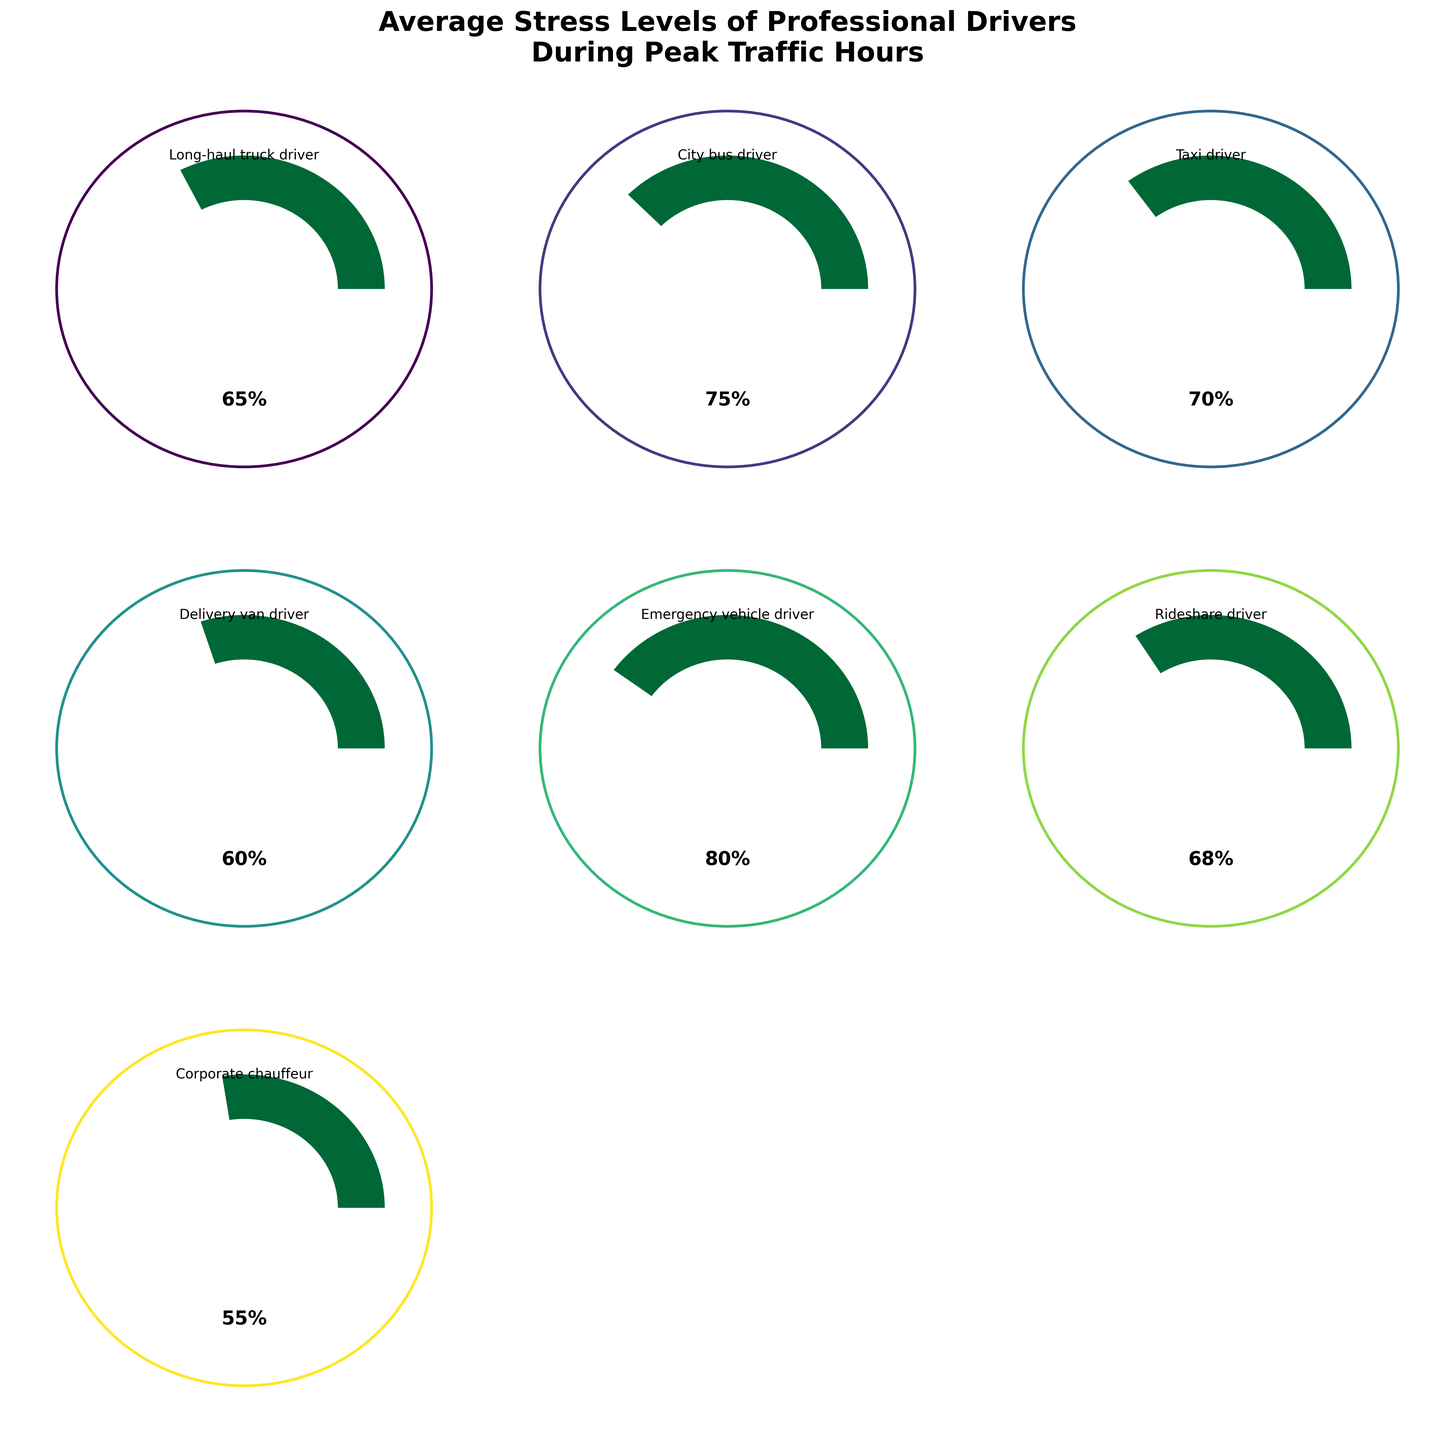What is the title of the figure? The title of the figure is usually the text displayed at the top of the chart. In this case, the title reads "Average Stress Levels of Professional Drivers\nDuring Peak Traffic Hours"
Answer: Average Stress Levels of Professional Drivers\nDuring Peak Traffic Hours How many driver types are displayed in the figure? The data provided lists seven types of professional drivers. The figure should display one gauge for each type of driver. Counting these will confirm the answer.
Answer: Seven Which driver type has the highest stress level? To determine the driver type with the highest stress level, locate the gauge showing the highest value of stress level. The stress level values are prominently displayed inside each gauge.
Answer: Emergency vehicle driver What is the average stress level of all professional drivers combined? Calculate the mean of all listed stress levels: (65 + 75 + 70 + 60 + 80 + 68 + 55)/7 = 473/7. Break down the numeric addition and division to determine the average.
Answer: 67.57 Compare the stress levels of the Taxi driver and the Rideshare driver. Which one is higher, and by how much? By examining the gauge charts for both the Taxi driver (70) and the Rideshare driver (68), we subtract the lesser value from the higher value: 70 - 68.
Answer: Taxi driver by 2% What is the range of stress levels among the drivers? Identify the maximum and minimum stress levels from the figure, then calculate the range as max - min. Maximum stress level is 80 and minimum is 55, so 80 - 55.
Answer: 25% Which driver type has the lowest stress level? Locate the gauge displaying the lowest stress level. The stress levels are prominently displayed within each gauge, making it easy to identify the lowest value.
Answer: Corporate chauffeur Is the stress level of a Delivery van driver above or below the average stress level of all drivers? First, determine the average stress level which is 67.57. Then compare this value to the stress level of a Delivery van driver (60).
Answer: Below How many driver types have stress levels above 70%? To find the number of driver types with stress levels above 70%, count the gauges showing stress levels greater than 70. From the data, only City bus driver (75) and Emergency vehicle driver (80) qualify.
Answer: Two What is the median stress level among all driver types? First, list the stress levels in ascending order: 55, 60, 65, 68, 70, 75, 80. The median stress level is the middle value in this ordered list.
Answer: 68 